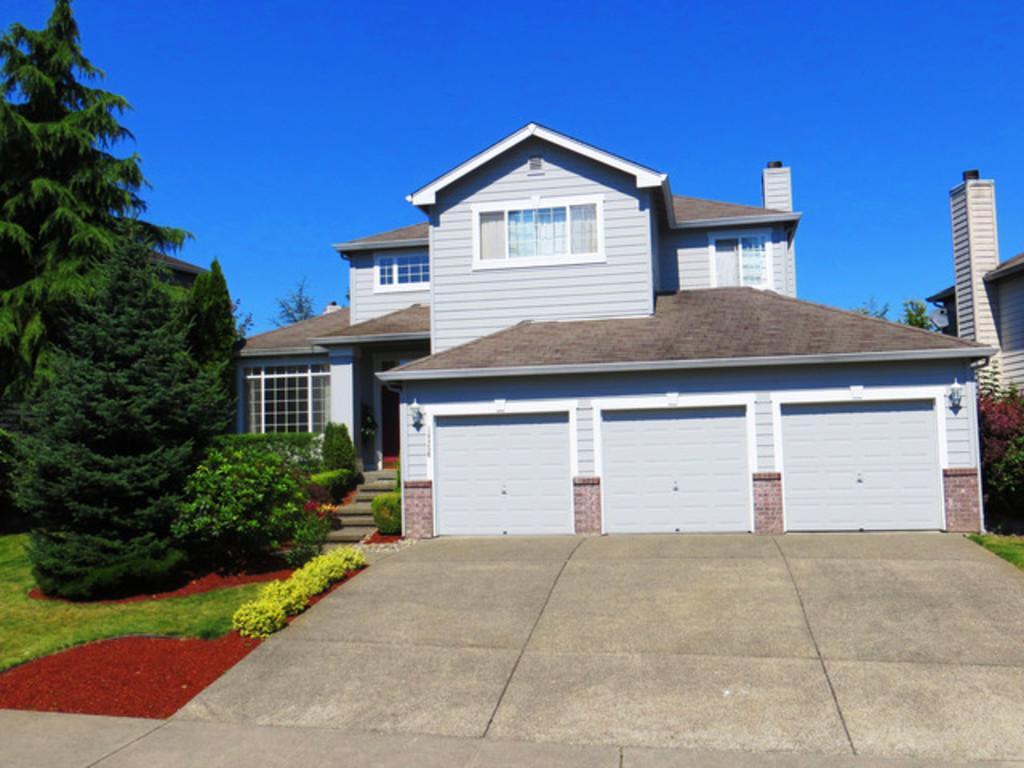Could you give a brief overview of what you see in this image? In this image I can see a building in the center. It has 3 shutters. There are trees on the left. There is sky at the top. 